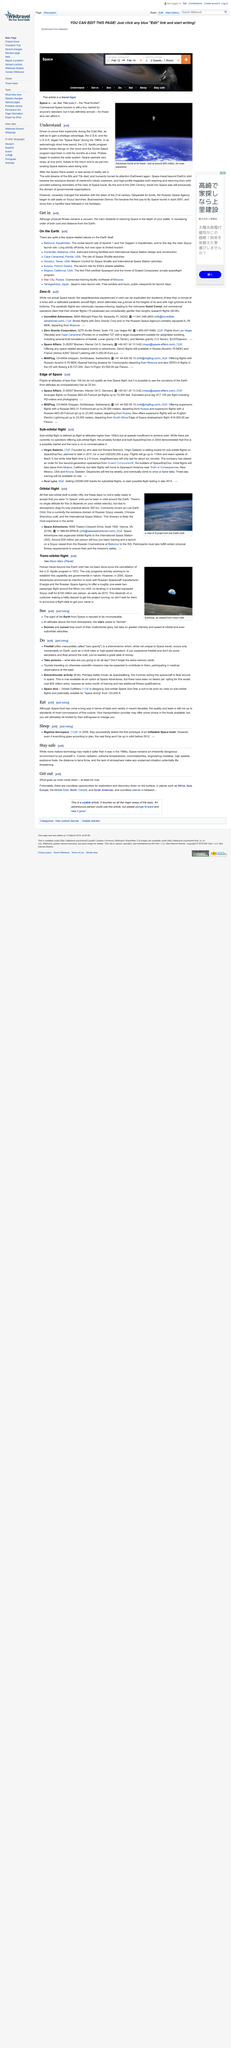Identify some key points in this picture. It is widely known that the Russian Soyuz, Chinese Shenzhou, and the International Space Station all utilize a specific type of orbit commonly referred to as Low Earth orbit. The U.S. moon landing program, known as Apollo, was a historic achievement in space exploration. The article is concerned with travel in space. The "Space Race" involved the United States and the Soviet Union, as two countries competing to be the first to achieve various milestones in space exploration. The Chinese vessels that orbit around the earth are known as Shenzhou craft. 